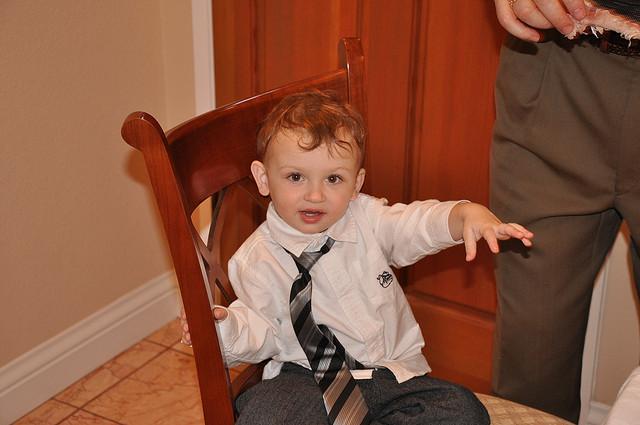What length is the boys pants?
Answer briefly. Long. What color is the boys tie?
Write a very short answer. Black and gray. Is the baby brushing his teeth?
Answer briefly. No. How many hands are free?
Short answer required. 1. What color is the door?
Concise answer only. Brown. What is the child holding?
Short answer required. Chair. What color hair does the little boy have?
Be succinct. Red. Why is the child wearing a bib?
Give a very brief answer. He's not. Is the chair scratched?
Be succinct. No. What is the child cutting?
Write a very short answer. Nothing. 